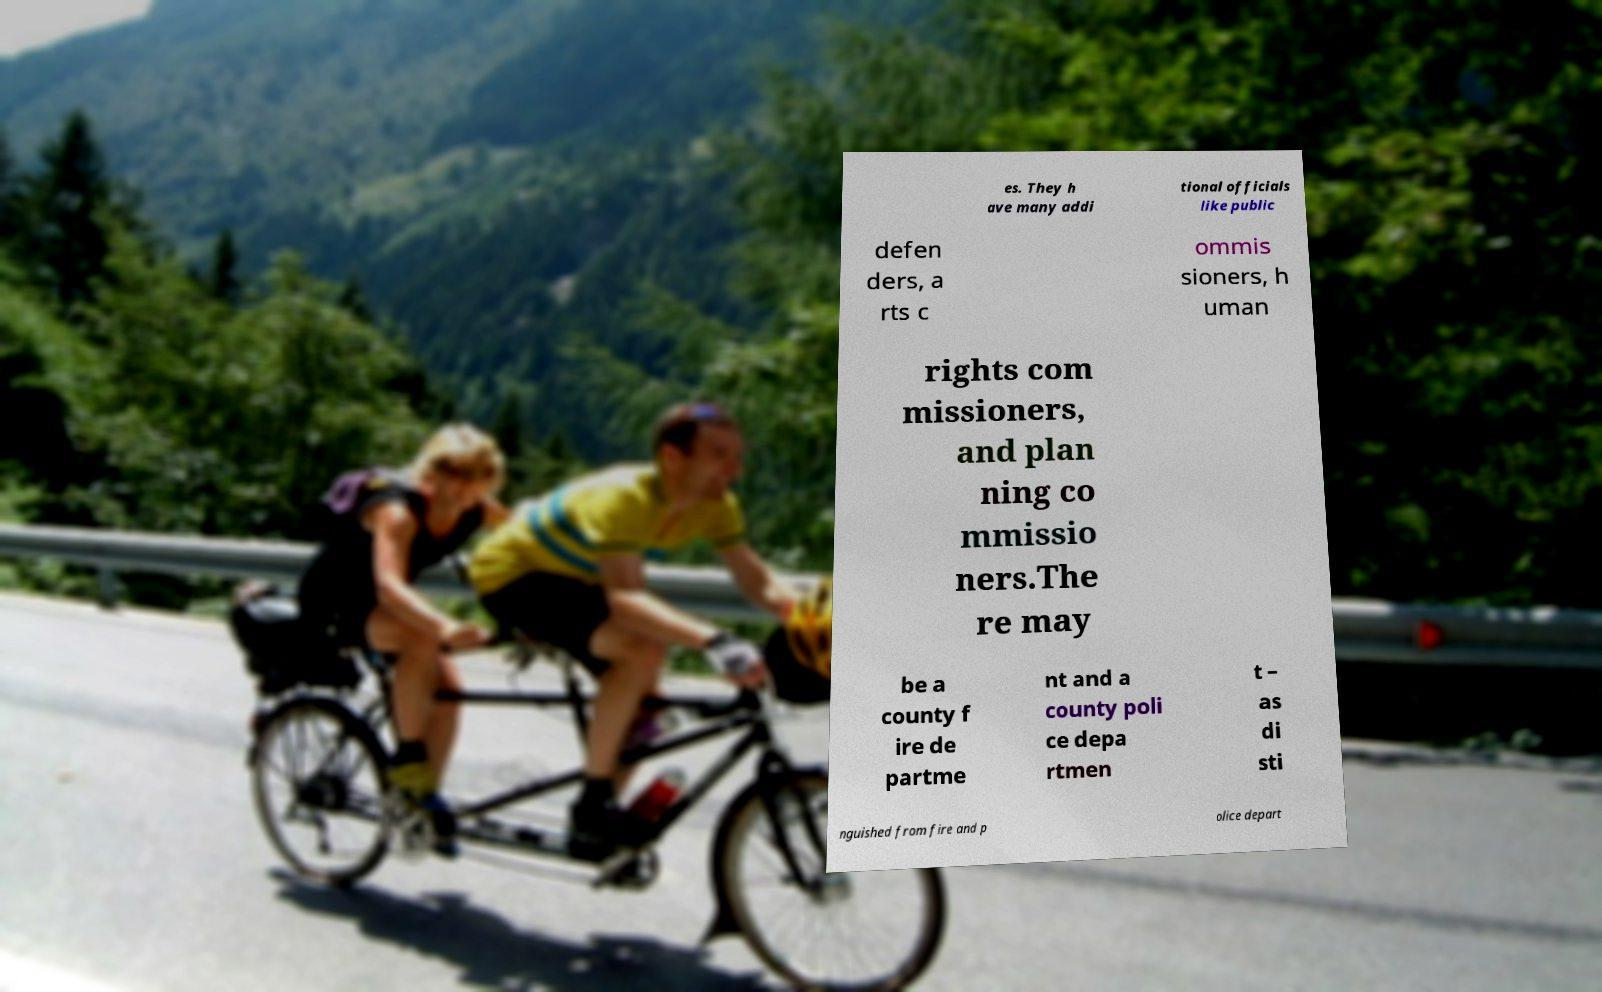Could you assist in decoding the text presented in this image and type it out clearly? es. They h ave many addi tional officials like public defen ders, a rts c ommis sioners, h uman rights com missioners, and plan ning co mmissio ners.The re may be a county f ire de partme nt and a county poli ce depa rtmen t – as di sti nguished from fire and p olice depart 